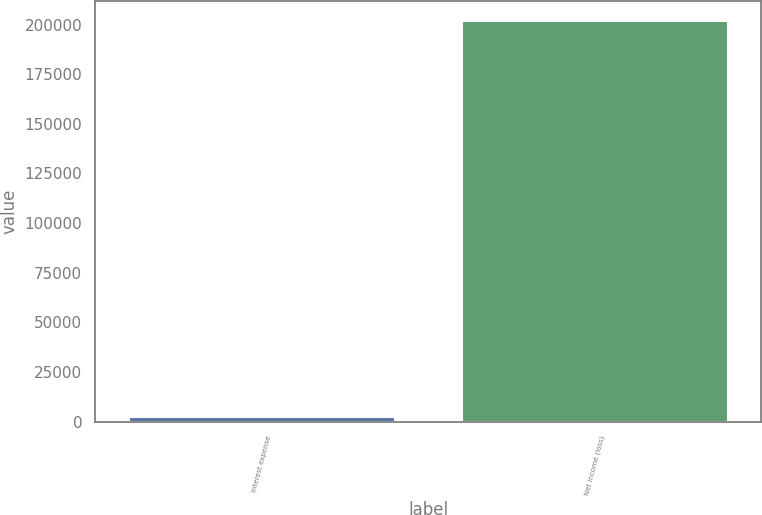Convert chart. <chart><loc_0><loc_0><loc_500><loc_500><bar_chart><fcel>Interest expense<fcel>Net income (loss)<nl><fcel>2357<fcel>201915<nl></chart> 